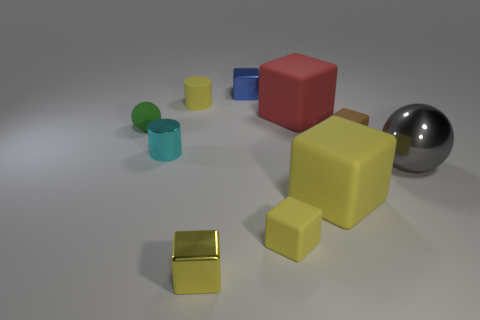Subtract all yellow cubes. How many were subtracted if there are1yellow cubes left? 2 Subtract all red cylinders. How many yellow cubes are left? 3 Subtract all large red blocks. How many blocks are left? 5 Subtract all red blocks. How many blocks are left? 5 Subtract all gray blocks. Subtract all yellow balls. How many blocks are left? 6 Subtract all spheres. How many objects are left? 8 Subtract 0 red cylinders. How many objects are left? 10 Subtract all cyan shiny cylinders. Subtract all tiny metallic cubes. How many objects are left? 7 Add 8 tiny cyan objects. How many tiny cyan objects are left? 9 Add 5 large cyan balls. How many large cyan balls exist? 5 